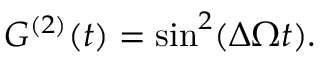Convert formula to latex. <formula><loc_0><loc_0><loc_500><loc_500>G ^ { ( 2 ) } ( t ) = \sin ^ { 2 } ( \Delta \Omega t ) .</formula> 